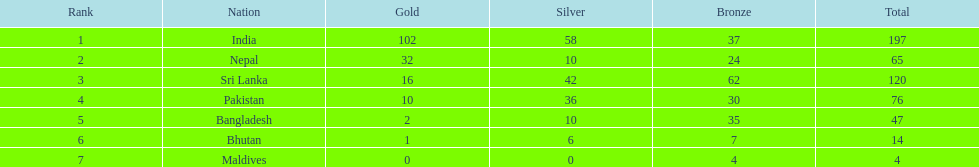How many gold medals did the teams earn in total? 102, 32, 16, 10, 2, 1, 0. Which country failed to win any gold medals? Maldives. 